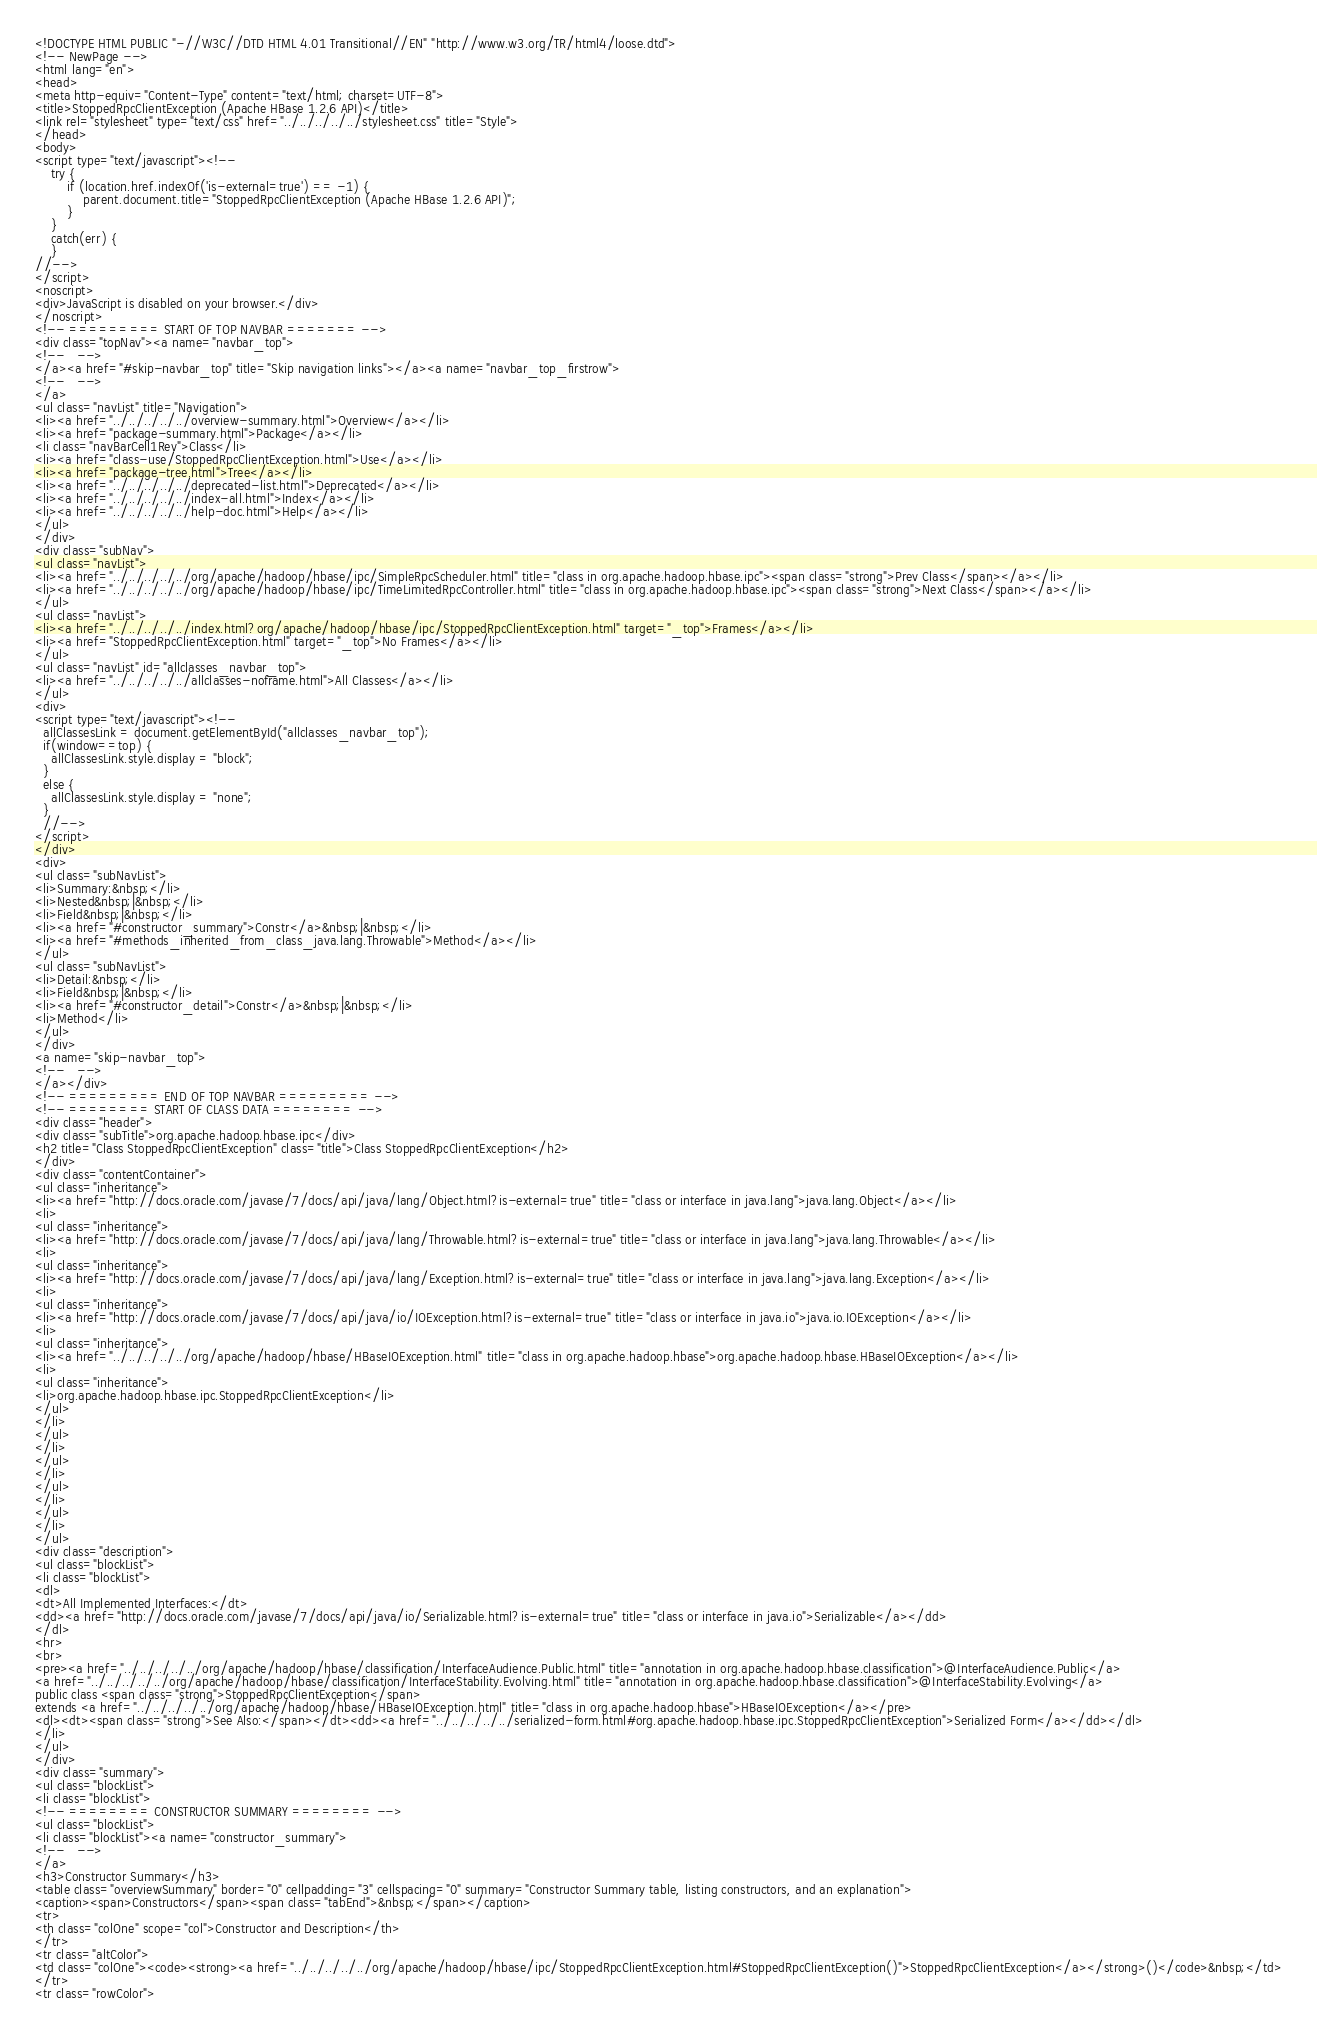<code> <loc_0><loc_0><loc_500><loc_500><_HTML_><!DOCTYPE HTML PUBLIC "-//W3C//DTD HTML 4.01 Transitional//EN" "http://www.w3.org/TR/html4/loose.dtd">
<!-- NewPage -->
<html lang="en">
<head>
<meta http-equiv="Content-Type" content="text/html; charset=UTF-8">
<title>StoppedRpcClientException (Apache HBase 1.2.6 API)</title>
<link rel="stylesheet" type="text/css" href="../../../../../stylesheet.css" title="Style">
</head>
<body>
<script type="text/javascript"><!--
    try {
        if (location.href.indexOf('is-external=true') == -1) {
            parent.document.title="StoppedRpcClientException (Apache HBase 1.2.6 API)";
        }
    }
    catch(err) {
    }
//-->
</script>
<noscript>
<div>JavaScript is disabled on your browser.</div>
</noscript>
<!-- ========= START OF TOP NAVBAR ======= -->
<div class="topNav"><a name="navbar_top">
<!--   -->
</a><a href="#skip-navbar_top" title="Skip navigation links"></a><a name="navbar_top_firstrow">
<!--   -->
</a>
<ul class="navList" title="Navigation">
<li><a href="../../../../../overview-summary.html">Overview</a></li>
<li><a href="package-summary.html">Package</a></li>
<li class="navBarCell1Rev">Class</li>
<li><a href="class-use/StoppedRpcClientException.html">Use</a></li>
<li><a href="package-tree.html">Tree</a></li>
<li><a href="../../../../../deprecated-list.html">Deprecated</a></li>
<li><a href="../../../../../index-all.html">Index</a></li>
<li><a href="../../../../../help-doc.html">Help</a></li>
</ul>
</div>
<div class="subNav">
<ul class="navList">
<li><a href="../../../../../org/apache/hadoop/hbase/ipc/SimpleRpcScheduler.html" title="class in org.apache.hadoop.hbase.ipc"><span class="strong">Prev Class</span></a></li>
<li><a href="../../../../../org/apache/hadoop/hbase/ipc/TimeLimitedRpcController.html" title="class in org.apache.hadoop.hbase.ipc"><span class="strong">Next Class</span></a></li>
</ul>
<ul class="navList">
<li><a href="../../../../../index.html?org/apache/hadoop/hbase/ipc/StoppedRpcClientException.html" target="_top">Frames</a></li>
<li><a href="StoppedRpcClientException.html" target="_top">No Frames</a></li>
</ul>
<ul class="navList" id="allclasses_navbar_top">
<li><a href="../../../../../allclasses-noframe.html">All Classes</a></li>
</ul>
<div>
<script type="text/javascript"><!--
  allClassesLink = document.getElementById("allclasses_navbar_top");
  if(window==top) {
    allClassesLink.style.display = "block";
  }
  else {
    allClassesLink.style.display = "none";
  }
  //-->
</script>
</div>
<div>
<ul class="subNavList">
<li>Summary:&nbsp;</li>
<li>Nested&nbsp;|&nbsp;</li>
<li>Field&nbsp;|&nbsp;</li>
<li><a href="#constructor_summary">Constr</a>&nbsp;|&nbsp;</li>
<li><a href="#methods_inherited_from_class_java.lang.Throwable">Method</a></li>
</ul>
<ul class="subNavList">
<li>Detail:&nbsp;</li>
<li>Field&nbsp;|&nbsp;</li>
<li><a href="#constructor_detail">Constr</a>&nbsp;|&nbsp;</li>
<li>Method</li>
</ul>
</div>
<a name="skip-navbar_top">
<!--   -->
</a></div>
<!-- ========= END OF TOP NAVBAR ========= -->
<!-- ======== START OF CLASS DATA ======== -->
<div class="header">
<div class="subTitle">org.apache.hadoop.hbase.ipc</div>
<h2 title="Class StoppedRpcClientException" class="title">Class StoppedRpcClientException</h2>
</div>
<div class="contentContainer">
<ul class="inheritance">
<li><a href="http://docs.oracle.com/javase/7/docs/api/java/lang/Object.html?is-external=true" title="class or interface in java.lang">java.lang.Object</a></li>
<li>
<ul class="inheritance">
<li><a href="http://docs.oracle.com/javase/7/docs/api/java/lang/Throwable.html?is-external=true" title="class or interface in java.lang">java.lang.Throwable</a></li>
<li>
<ul class="inheritance">
<li><a href="http://docs.oracle.com/javase/7/docs/api/java/lang/Exception.html?is-external=true" title="class or interface in java.lang">java.lang.Exception</a></li>
<li>
<ul class="inheritance">
<li><a href="http://docs.oracle.com/javase/7/docs/api/java/io/IOException.html?is-external=true" title="class or interface in java.io">java.io.IOException</a></li>
<li>
<ul class="inheritance">
<li><a href="../../../../../org/apache/hadoop/hbase/HBaseIOException.html" title="class in org.apache.hadoop.hbase">org.apache.hadoop.hbase.HBaseIOException</a></li>
<li>
<ul class="inheritance">
<li>org.apache.hadoop.hbase.ipc.StoppedRpcClientException</li>
</ul>
</li>
</ul>
</li>
</ul>
</li>
</ul>
</li>
</ul>
</li>
</ul>
<div class="description">
<ul class="blockList">
<li class="blockList">
<dl>
<dt>All Implemented Interfaces:</dt>
<dd><a href="http://docs.oracle.com/javase/7/docs/api/java/io/Serializable.html?is-external=true" title="class or interface in java.io">Serializable</a></dd>
</dl>
<hr>
<br>
<pre><a href="../../../../../org/apache/hadoop/hbase/classification/InterfaceAudience.Public.html" title="annotation in org.apache.hadoop.hbase.classification">@InterfaceAudience.Public</a>
<a href="../../../../../org/apache/hadoop/hbase/classification/InterfaceStability.Evolving.html" title="annotation in org.apache.hadoop.hbase.classification">@InterfaceStability.Evolving</a>
public class <span class="strong">StoppedRpcClientException</span>
extends <a href="../../../../../org/apache/hadoop/hbase/HBaseIOException.html" title="class in org.apache.hadoop.hbase">HBaseIOException</a></pre>
<dl><dt><span class="strong">See Also:</span></dt><dd><a href="../../../../../serialized-form.html#org.apache.hadoop.hbase.ipc.StoppedRpcClientException">Serialized Form</a></dd></dl>
</li>
</ul>
</div>
<div class="summary">
<ul class="blockList">
<li class="blockList">
<!-- ======== CONSTRUCTOR SUMMARY ======== -->
<ul class="blockList">
<li class="blockList"><a name="constructor_summary">
<!--   -->
</a>
<h3>Constructor Summary</h3>
<table class="overviewSummary" border="0" cellpadding="3" cellspacing="0" summary="Constructor Summary table, listing constructors, and an explanation">
<caption><span>Constructors</span><span class="tabEnd">&nbsp;</span></caption>
<tr>
<th class="colOne" scope="col">Constructor and Description</th>
</tr>
<tr class="altColor">
<td class="colOne"><code><strong><a href="../../../../../org/apache/hadoop/hbase/ipc/StoppedRpcClientException.html#StoppedRpcClientException()">StoppedRpcClientException</a></strong>()</code>&nbsp;</td>
</tr>
<tr class="rowColor"></code> 